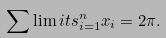<formula> <loc_0><loc_0><loc_500><loc_500>\sum \lim i t s _ { i = 1 } ^ { n } x _ { i } = 2 \pi .</formula> 